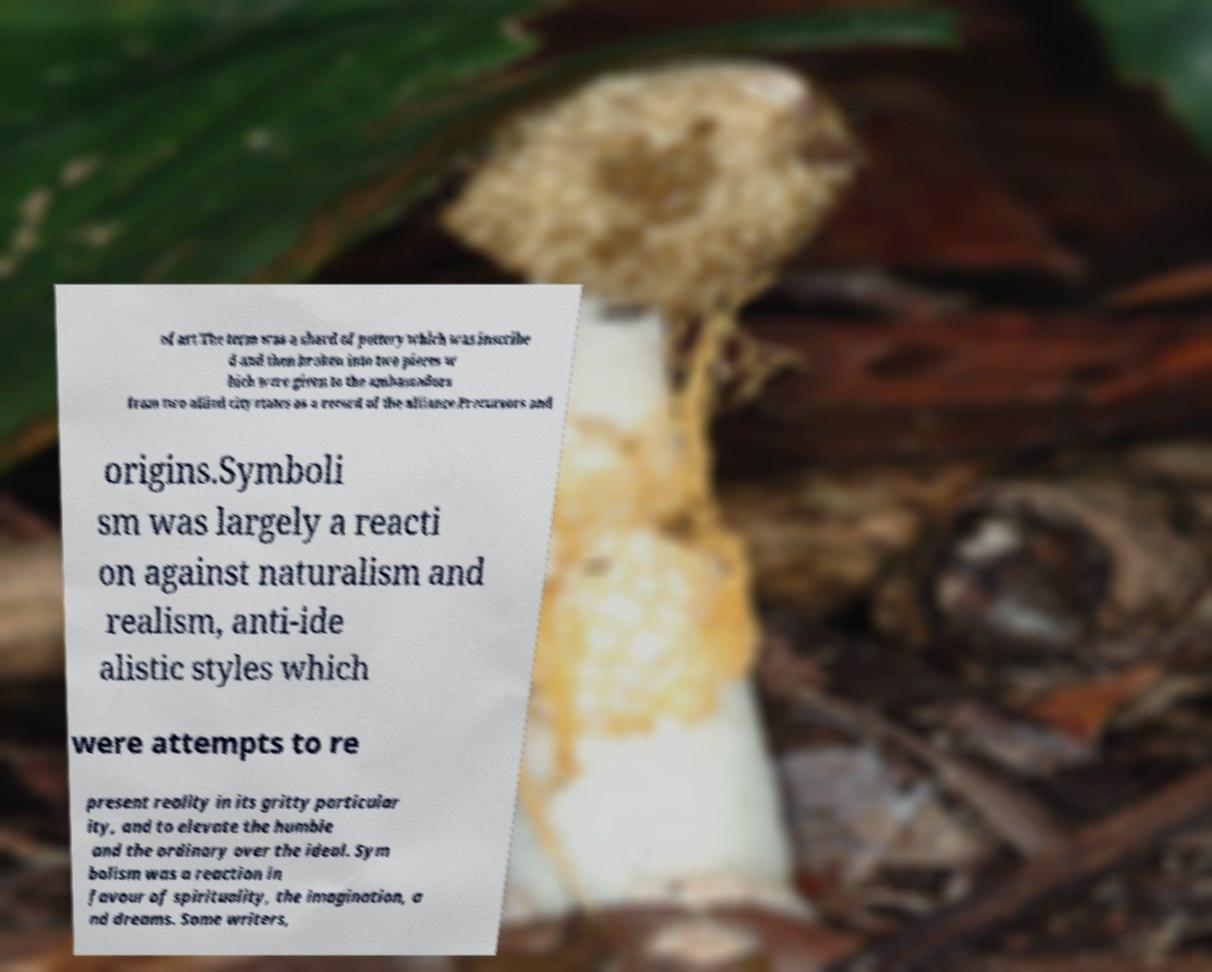Please read and relay the text visible in this image. What does it say? of art.The term was a shard of pottery which was inscribe d and then broken into two pieces w hich were given to the ambassadors from two allied city states as a record of the alliance.Precursors and origins.Symboli sm was largely a reacti on against naturalism and realism, anti-ide alistic styles which were attempts to re present reality in its gritty particular ity, and to elevate the humble and the ordinary over the ideal. Sym bolism was a reaction in favour of spirituality, the imagination, a nd dreams. Some writers, 